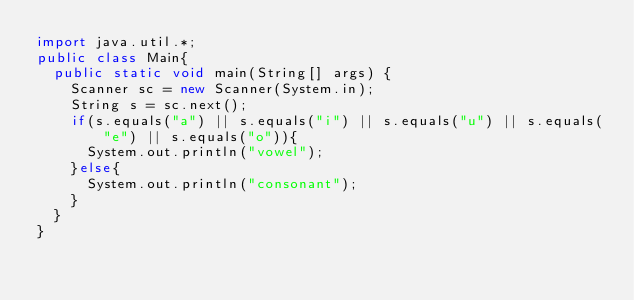Convert code to text. <code><loc_0><loc_0><loc_500><loc_500><_Java_>import java.util.*;
public class Main{
  public static void main(String[] args) {
    Scanner sc = new Scanner(System.in);
    String s = sc.next();
    if(s.equals("a") || s.equals("i") || s.equals("u") || s.equals("e") || s.equals("o")){
      System.out.println("vowel");
    }else{
      System.out.println("consonant");
    }
  }
}
</code> 